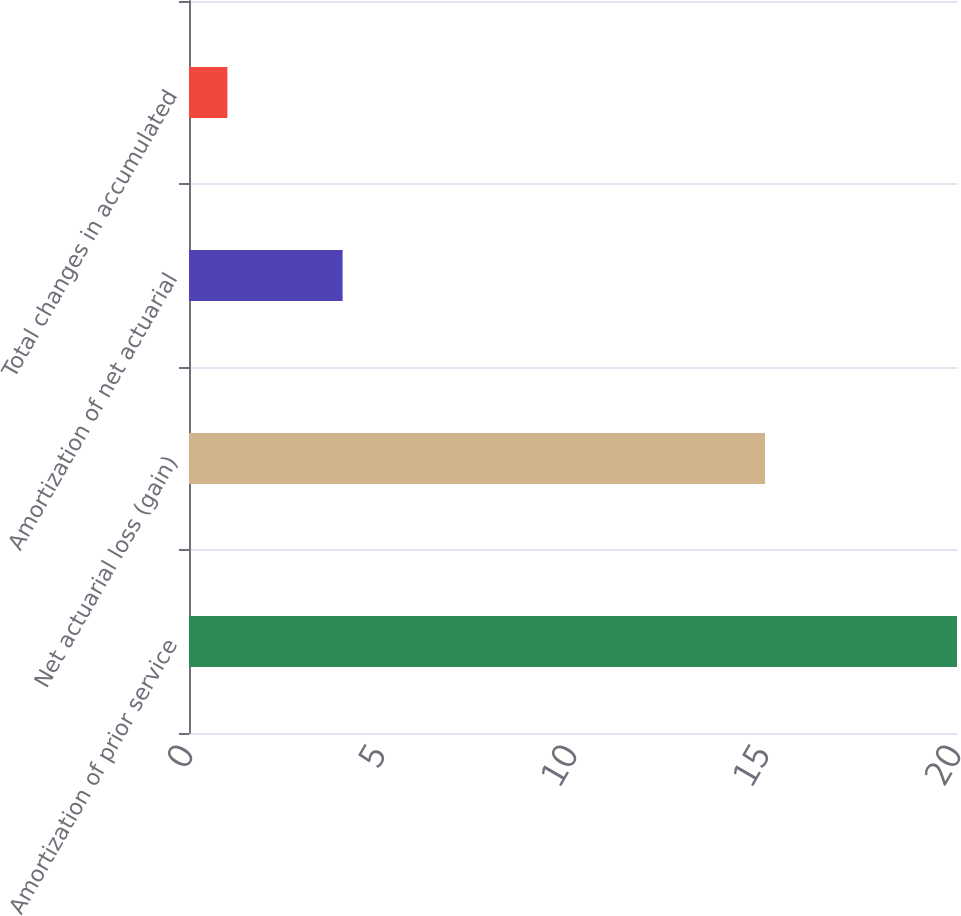<chart> <loc_0><loc_0><loc_500><loc_500><bar_chart><fcel>Amortization of prior service<fcel>Net actuarial loss (gain)<fcel>Amortization of net actuarial<fcel>Total changes in accumulated<nl><fcel>20<fcel>15<fcel>4<fcel>1<nl></chart> 